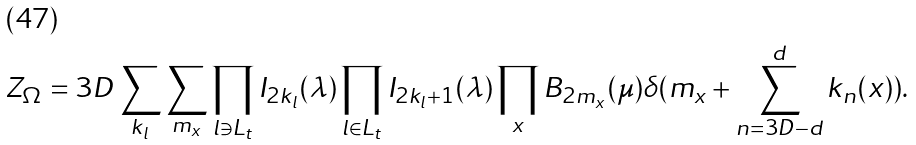<formula> <loc_0><loc_0><loc_500><loc_500>Z _ { \Omega } = 3 D \sum _ { k _ { l } } \sum _ { m _ { x } } \prod _ { l \ni L _ { t } } I _ { 2 k _ { l } } ( \lambda ) \prod _ { l \in L _ { t } } I _ { 2 k _ { l } + 1 } ( \lambda ) \prod _ { x } B _ { 2 m _ { x } } ( \mu ) \delta ( m _ { x } + \sum _ { n = 3 D - d } ^ { d } k _ { n } ( x ) ) .</formula> 